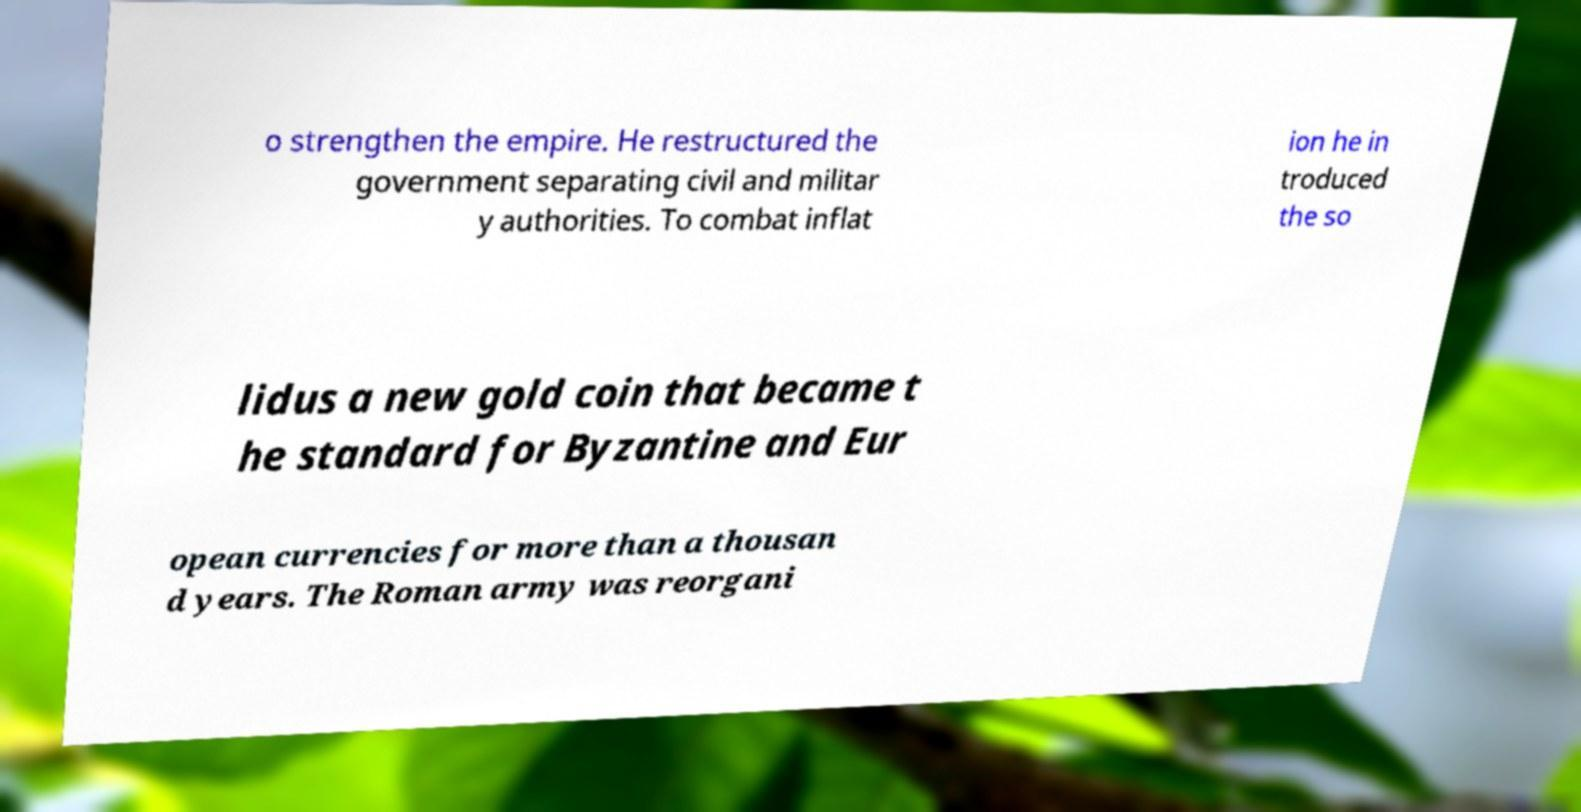Please identify and transcribe the text found in this image. o strengthen the empire. He restructured the government separating civil and militar y authorities. To combat inflat ion he in troduced the so lidus a new gold coin that became t he standard for Byzantine and Eur opean currencies for more than a thousan d years. The Roman army was reorgani 